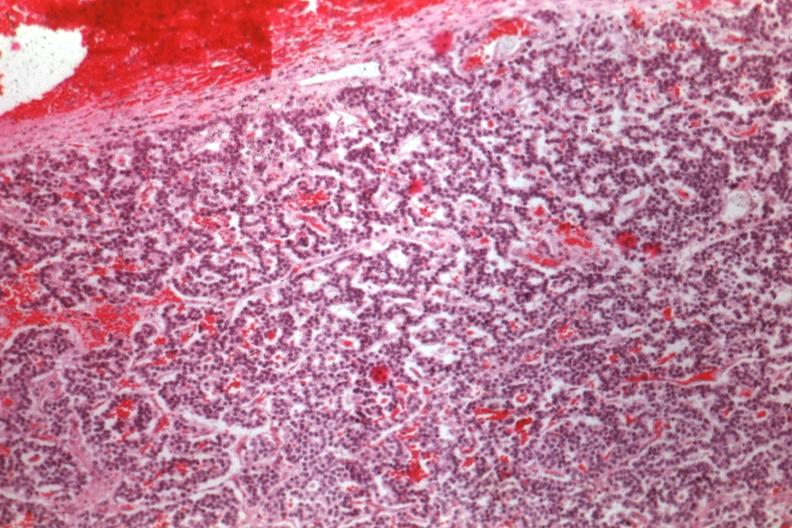s this image present?
Answer the question using a single word or phrase. No 